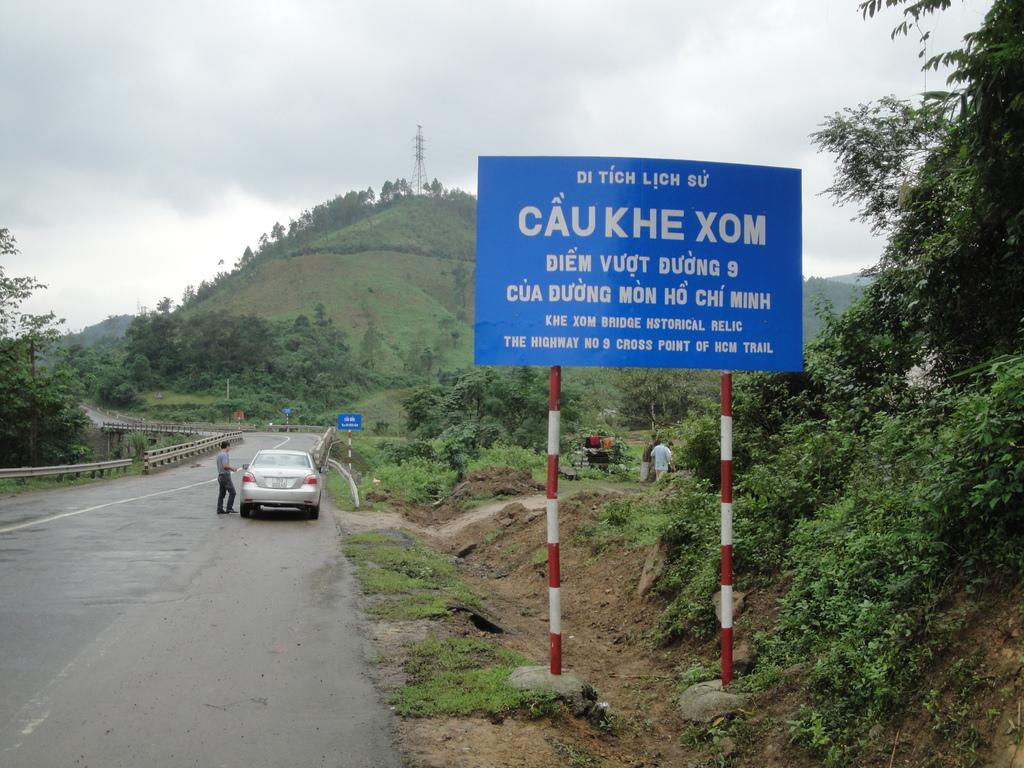In one or two sentences, can you explain what this image depicts? On the left side of the picture there are trees, plants, soil and a board. On the right there are trees, road, vehicle and a person. In the background there are trees, plants, grass, sign boards, tower and hills. Sky is sunny. 